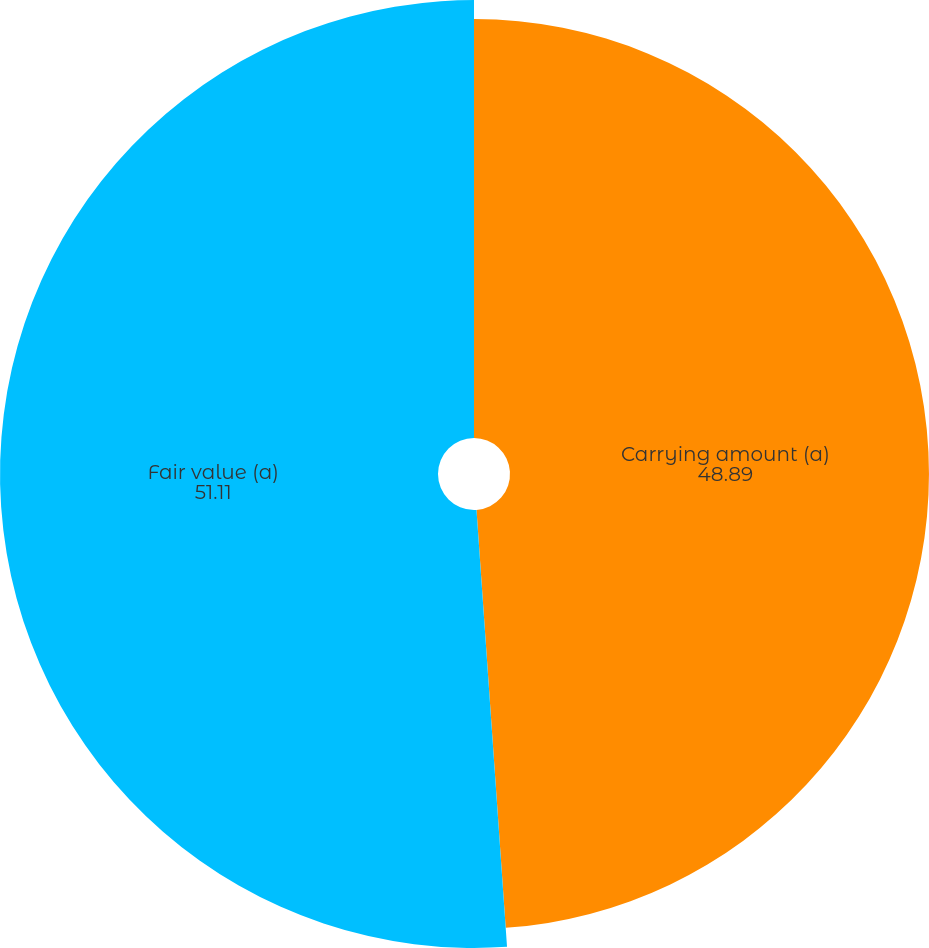Convert chart to OTSL. <chart><loc_0><loc_0><loc_500><loc_500><pie_chart><fcel>Carrying amount (a)<fcel>Fair value (a)<nl><fcel>48.89%<fcel>51.11%<nl></chart> 